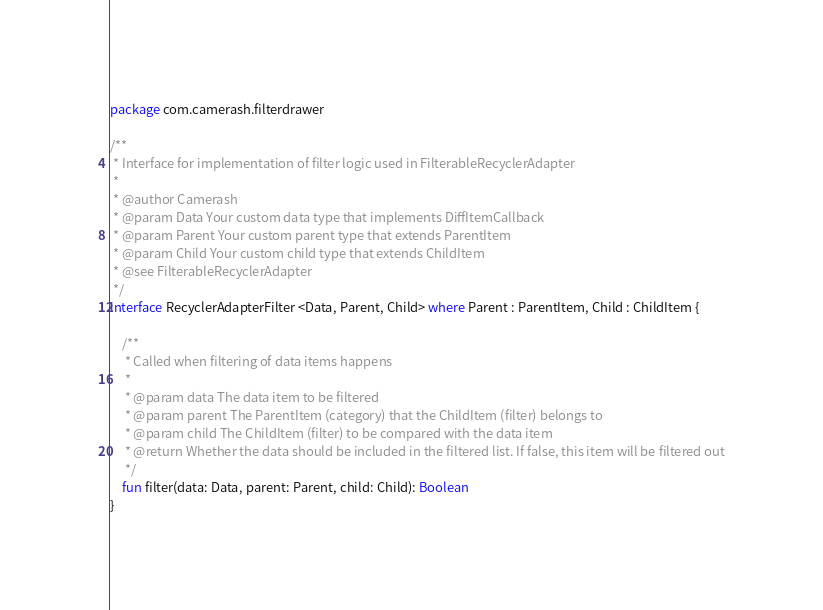<code> <loc_0><loc_0><loc_500><loc_500><_Kotlin_>package com.camerash.filterdrawer

/**
 * Interface for implementation of filter logic used in FilterableRecyclerAdapter
 *
 * @author Camerash
 * @param Data Your custom data type that implements DiffItemCallback
 * @param Parent Your custom parent type that extends ParentItem
 * @param Child Your custom child type that extends ChildItem
 * @see FilterableRecyclerAdapter
 */
interface RecyclerAdapterFilter <Data, Parent, Child> where Parent : ParentItem, Child : ChildItem {

    /**
     * Called when filtering of data items happens
     *
     * @param data The data item to be filtered
     * @param parent The ParentItem (category) that the ChildItem (filter) belongs to
     * @param child The ChildItem (filter) to be compared with the data item
     * @return Whether the data should be included in the filtered list. If false, this item will be filtered out
     */
    fun filter(data: Data, parent: Parent, child: Child): Boolean
}</code> 